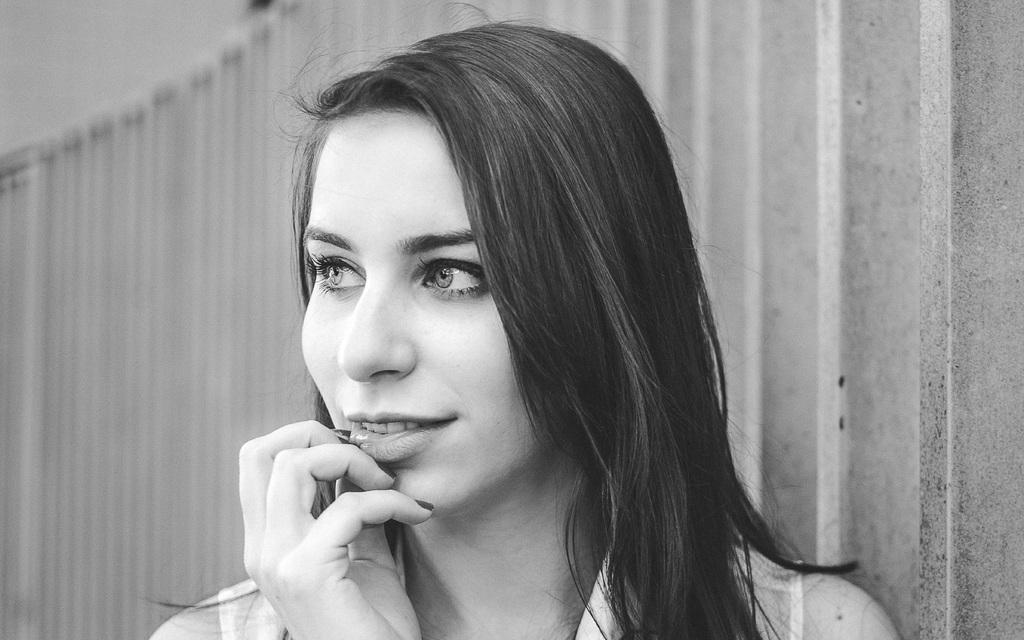What is the color scheme of the image? The image is black and white. Who is present in the image? There is a woman in the image. In which direction is the woman looking? The woman is looking towards the left side. How is the background of the woman depicted? The background of the woman is blurred. What level of skill does the woman have in the image? There is no indication of the woman's skill level in the image. What activity is taking place during the recess in the image? There is no recess or any activity taking place in the image; it is a still photograph of a woman. 